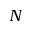Convert formula to latex. <formula><loc_0><loc_0><loc_500><loc_500>N</formula> 